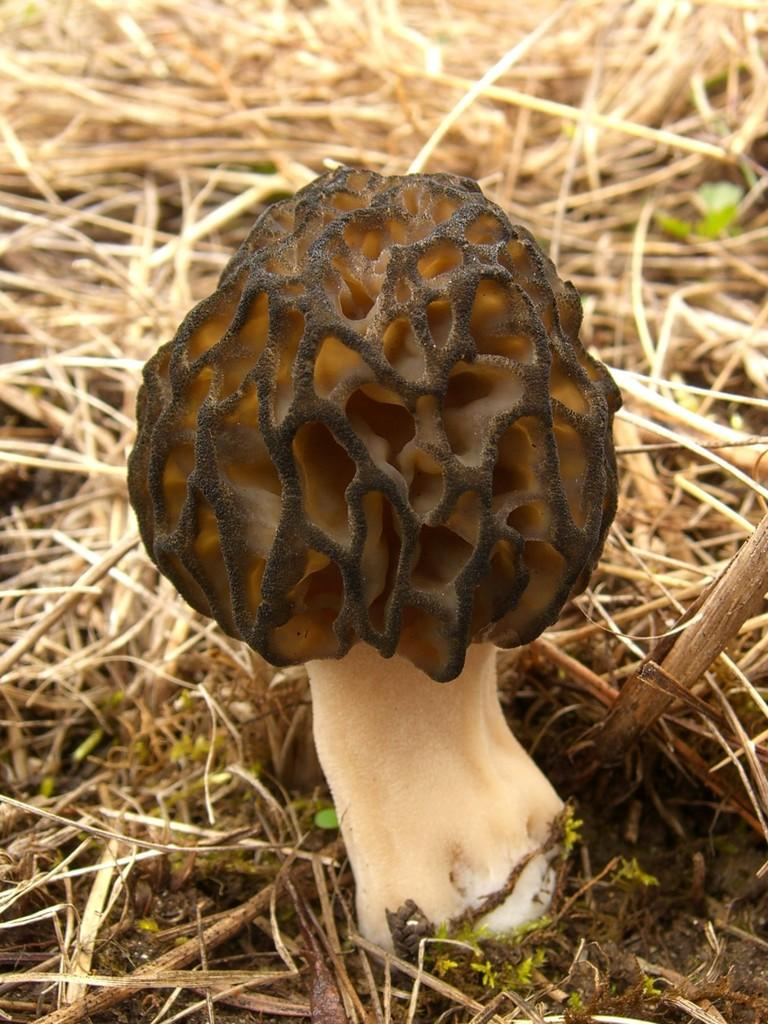What is the main subject of the image? The main subject of the image is a mushroom. Can you describe the colors of the mushroom? The mushroom has cream, brown, and black colors. Where is the mushroom located in the image? The mushroom is on the ground. What type of vegetation is present on the ground in the image? There is grass on the ground in the image. Can you describe the colors of the grass? The grass has cream and green colors. Can you tell me how many pins are stuck in the mushroom in the image? There are no pins present in the image; it features a mushroom on the ground with grass. What type of animal is licking the mushroom in the image? There is no animal present in the image, let alone one licking the mushroom. 